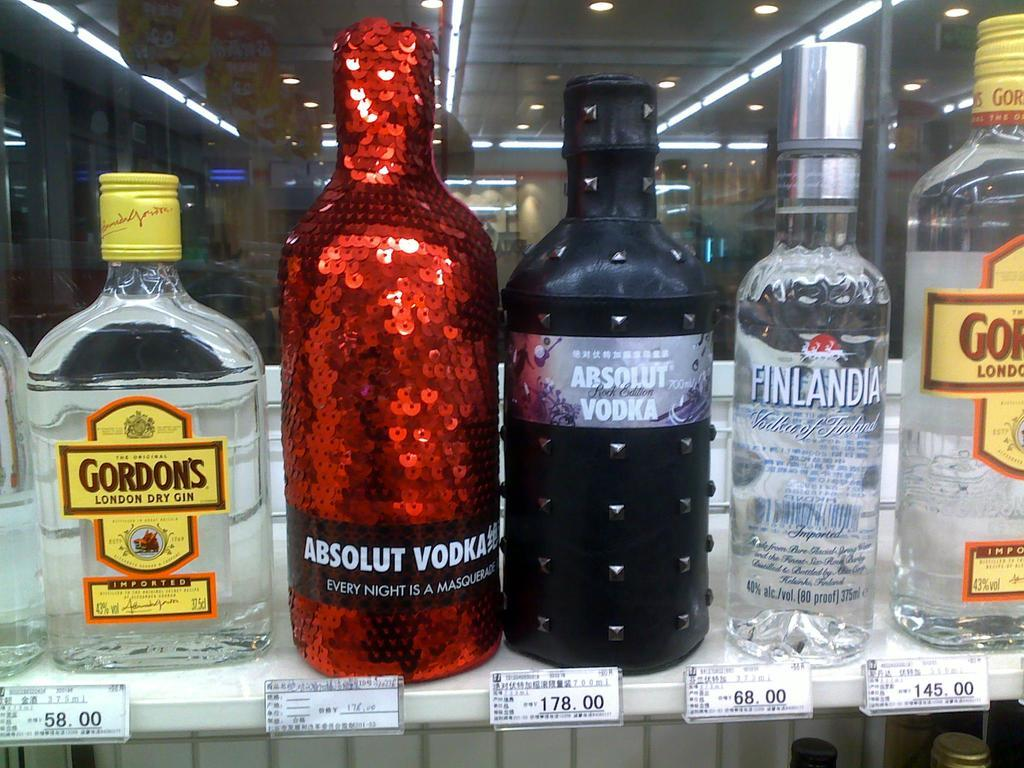<image>
Share a concise interpretation of the image provided. A bottle of Absolute Vodka is surrounded by other bottles. 